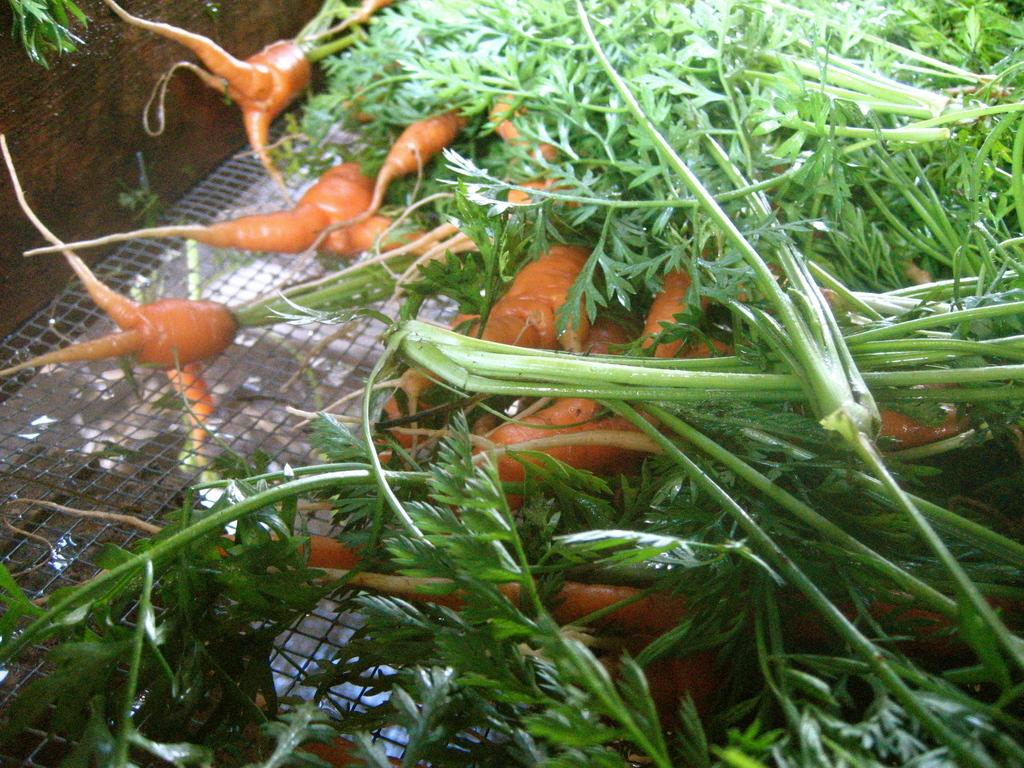What type of vegetables can be seen in the image? There are carrots in the image. What other living organisms are present in the image? There are plants in the image. How much money is being exchanged between the carrots in the image? There is no money being exchanged in the image, as it features carrots and plants. What type of waste can be seen in the image? There is no waste present in the image; it features carrots and plants. 